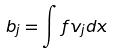Convert formula to latex. <formula><loc_0><loc_0><loc_500><loc_500>b _ { j } = \int f v _ { j } d x</formula> 